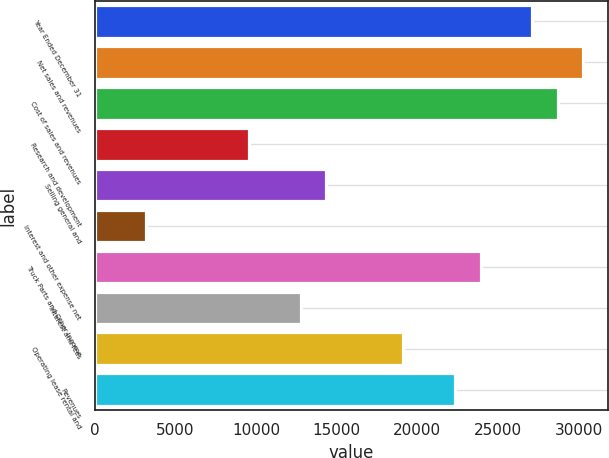Convert chart to OTSL. <chart><loc_0><loc_0><loc_500><loc_500><bar_chart><fcel>Year Ended December 31<fcel>Net sales and revenues<fcel>Cost of sales and revenues<fcel>Research and development<fcel>Selling general and<fcel>Interest and other expense net<fcel>Truck Parts and Other Income<fcel>Interest and fees<fcel>Operating lease rental and<fcel>Revenues<nl><fcel>27110.8<fcel>30299.9<fcel>28705.4<fcel>9570.66<fcel>14354.3<fcel>3192.42<fcel>23921.7<fcel>12759.8<fcel>19138<fcel>22327.1<nl></chart> 